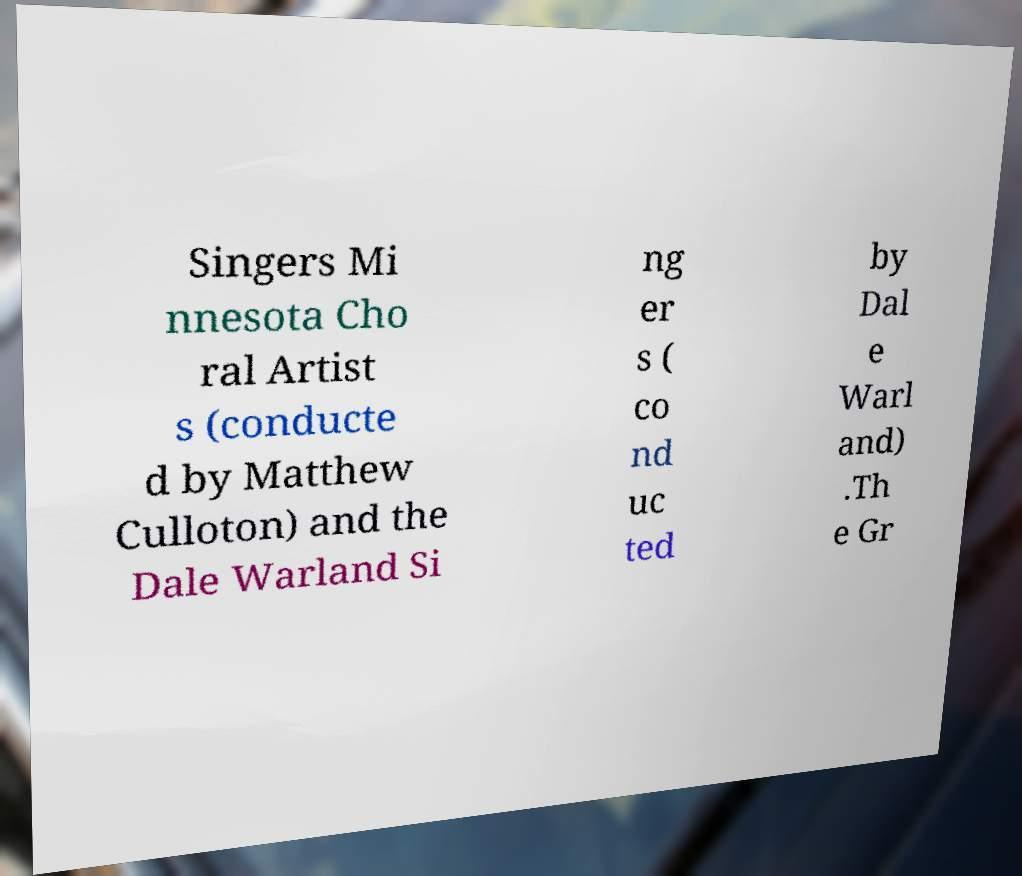Can you read and provide the text displayed in the image?This photo seems to have some interesting text. Can you extract and type it out for me? Singers Mi nnesota Cho ral Artist s (conducte d by Matthew Culloton) and the Dale Warland Si ng er s ( co nd uc ted by Dal e Warl and) .Th e Gr 